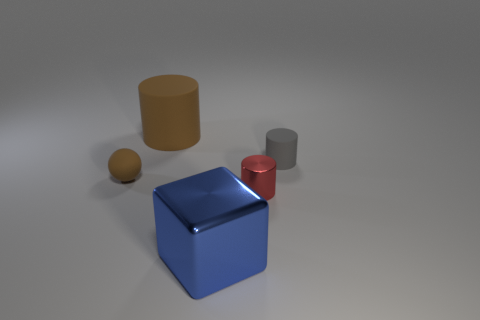There is a thing that is the same color as the large cylinder; what is its material?
Your response must be concise. Rubber. There is a small matte object that is behind the tiny rubber sphere; does it have the same shape as the large brown matte object?
Make the answer very short. Yes. What number of objects are either small metallic cylinders or small matte objects that are on the left side of the shiny block?
Your response must be concise. 2. Is the big object behind the blue block made of the same material as the large blue object?
Provide a short and direct response. No. Are there any other things that are the same size as the red cylinder?
Offer a very short reply. Yes. There is a thing that is on the left side of the large thing that is to the left of the big blue cube; what is its material?
Give a very brief answer. Rubber. Are there more large objects that are right of the large blue metal object than red things that are to the right of the small metallic cylinder?
Make the answer very short. No. The brown matte cylinder is what size?
Your answer should be compact. Large. Does the large object to the left of the large blue block have the same color as the big shiny object?
Your response must be concise. No. Is there any other thing that is the same shape as the blue object?
Your answer should be compact. No. 